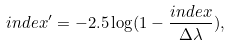<formula> <loc_0><loc_0><loc_500><loc_500>i n d e x ^ { \prime } = - 2 . 5 \log ( 1 - \frac { i n d e x } { \Delta \lambda } ) ,</formula> 